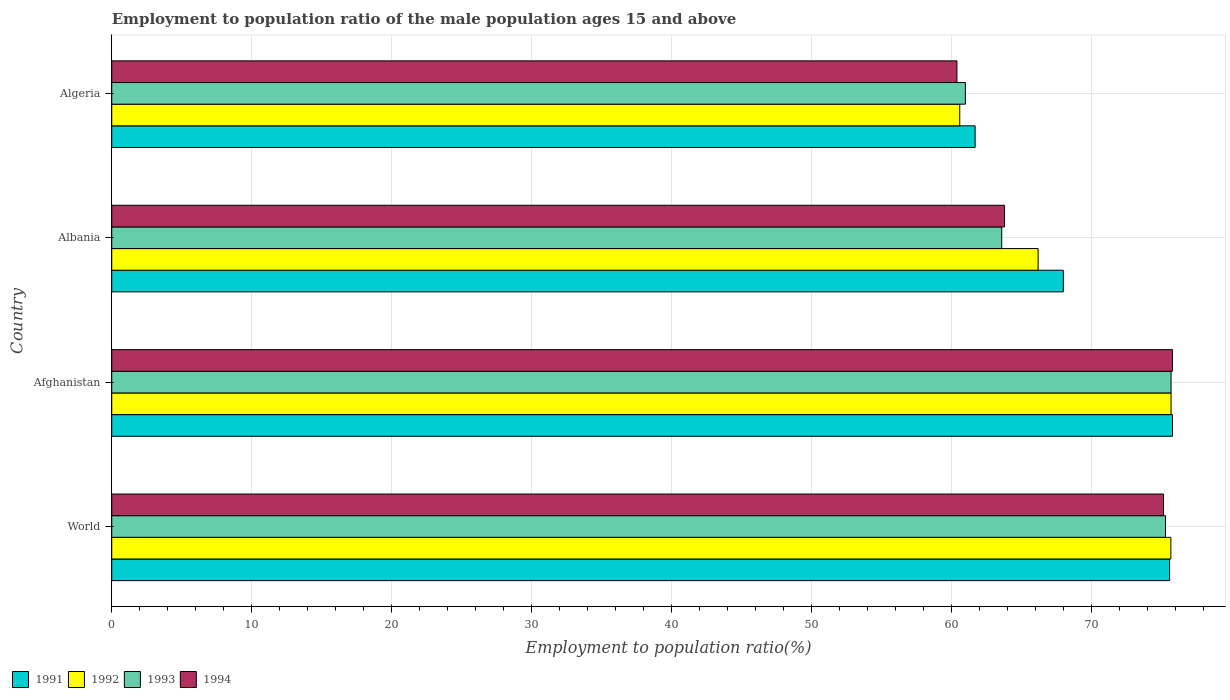Are the number of bars per tick equal to the number of legend labels?
Give a very brief answer. Yes. Are the number of bars on each tick of the Y-axis equal?
Keep it short and to the point. Yes. In how many cases, is the number of bars for a given country not equal to the number of legend labels?
Provide a short and direct response. 0. What is the employment to population ratio in 1994 in Albania?
Offer a terse response. 63.8. Across all countries, what is the maximum employment to population ratio in 1994?
Provide a succinct answer. 75.8. Across all countries, what is the minimum employment to population ratio in 1992?
Offer a terse response. 60.6. In which country was the employment to population ratio in 1993 maximum?
Ensure brevity in your answer.  Afghanistan. In which country was the employment to population ratio in 1994 minimum?
Your answer should be very brief. Algeria. What is the total employment to population ratio in 1994 in the graph?
Provide a succinct answer. 275.16. What is the difference between the employment to population ratio in 1992 in Afghanistan and that in Algeria?
Your answer should be compact. 15.1. What is the difference between the employment to population ratio in 1992 in Afghanistan and the employment to population ratio in 1991 in Algeria?
Provide a short and direct response. 14. What is the average employment to population ratio in 1994 per country?
Your answer should be compact. 68.79. What is the difference between the employment to population ratio in 1993 and employment to population ratio in 1992 in World?
Make the answer very short. -0.38. In how many countries, is the employment to population ratio in 1993 greater than 70 %?
Offer a very short reply. 2. What is the ratio of the employment to population ratio in 1993 in Albania to that in Algeria?
Offer a terse response. 1.04. Is the employment to population ratio in 1992 in Albania less than that in World?
Your response must be concise. Yes. What is the difference between the highest and the second highest employment to population ratio in 1991?
Your answer should be very brief. 0.2. What is the difference between the highest and the lowest employment to population ratio in 1994?
Your answer should be compact. 15.4. In how many countries, is the employment to population ratio in 1993 greater than the average employment to population ratio in 1993 taken over all countries?
Make the answer very short. 2. Is it the case that in every country, the sum of the employment to population ratio in 1991 and employment to population ratio in 1992 is greater than the sum of employment to population ratio in 1994 and employment to population ratio in 1993?
Give a very brief answer. No. What does the 4th bar from the top in Afghanistan represents?
Offer a very short reply. 1991. What does the 3rd bar from the bottom in World represents?
Provide a short and direct response. 1993. Is it the case that in every country, the sum of the employment to population ratio in 1993 and employment to population ratio in 1992 is greater than the employment to population ratio in 1994?
Make the answer very short. Yes. How many bars are there?
Your answer should be compact. 16. What is the difference between two consecutive major ticks on the X-axis?
Make the answer very short. 10. What is the title of the graph?
Make the answer very short. Employment to population ratio of the male population ages 15 and above. What is the label or title of the X-axis?
Offer a terse response. Employment to population ratio(%). What is the Employment to population ratio(%) in 1991 in World?
Ensure brevity in your answer.  75.6. What is the Employment to population ratio(%) in 1992 in World?
Your answer should be compact. 75.69. What is the Employment to population ratio(%) of 1993 in World?
Make the answer very short. 75.3. What is the Employment to population ratio(%) of 1994 in World?
Offer a very short reply. 75.16. What is the Employment to population ratio(%) in 1991 in Afghanistan?
Provide a short and direct response. 75.8. What is the Employment to population ratio(%) in 1992 in Afghanistan?
Give a very brief answer. 75.7. What is the Employment to population ratio(%) in 1993 in Afghanistan?
Provide a short and direct response. 75.7. What is the Employment to population ratio(%) of 1994 in Afghanistan?
Offer a terse response. 75.8. What is the Employment to population ratio(%) of 1991 in Albania?
Keep it short and to the point. 68. What is the Employment to population ratio(%) in 1992 in Albania?
Your response must be concise. 66.2. What is the Employment to population ratio(%) of 1993 in Albania?
Offer a very short reply. 63.6. What is the Employment to population ratio(%) of 1994 in Albania?
Offer a terse response. 63.8. What is the Employment to population ratio(%) of 1991 in Algeria?
Keep it short and to the point. 61.7. What is the Employment to population ratio(%) in 1992 in Algeria?
Give a very brief answer. 60.6. What is the Employment to population ratio(%) of 1993 in Algeria?
Offer a terse response. 61. What is the Employment to population ratio(%) in 1994 in Algeria?
Your response must be concise. 60.4. Across all countries, what is the maximum Employment to population ratio(%) of 1991?
Keep it short and to the point. 75.8. Across all countries, what is the maximum Employment to population ratio(%) in 1992?
Provide a short and direct response. 75.7. Across all countries, what is the maximum Employment to population ratio(%) in 1993?
Provide a short and direct response. 75.7. Across all countries, what is the maximum Employment to population ratio(%) of 1994?
Your answer should be compact. 75.8. Across all countries, what is the minimum Employment to population ratio(%) in 1991?
Your response must be concise. 61.7. Across all countries, what is the minimum Employment to population ratio(%) of 1992?
Offer a terse response. 60.6. Across all countries, what is the minimum Employment to population ratio(%) of 1994?
Make the answer very short. 60.4. What is the total Employment to population ratio(%) in 1991 in the graph?
Provide a short and direct response. 281.1. What is the total Employment to population ratio(%) in 1992 in the graph?
Ensure brevity in your answer.  278.19. What is the total Employment to population ratio(%) in 1993 in the graph?
Offer a terse response. 275.6. What is the total Employment to population ratio(%) of 1994 in the graph?
Offer a very short reply. 275.16. What is the difference between the Employment to population ratio(%) in 1991 in World and that in Afghanistan?
Offer a very short reply. -0.2. What is the difference between the Employment to population ratio(%) in 1992 in World and that in Afghanistan?
Provide a short and direct response. -0.01. What is the difference between the Employment to population ratio(%) of 1993 in World and that in Afghanistan?
Keep it short and to the point. -0.4. What is the difference between the Employment to population ratio(%) of 1994 in World and that in Afghanistan?
Give a very brief answer. -0.64. What is the difference between the Employment to population ratio(%) of 1991 in World and that in Albania?
Your answer should be compact. 7.6. What is the difference between the Employment to population ratio(%) in 1992 in World and that in Albania?
Provide a succinct answer. 9.49. What is the difference between the Employment to population ratio(%) of 1993 in World and that in Albania?
Offer a terse response. 11.7. What is the difference between the Employment to population ratio(%) of 1994 in World and that in Albania?
Give a very brief answer. 11.36. What is the difference between the Employment to population ratio(%) of 1991 in World and that in Algeria?
Keep it short and to the point. 13.9. What is the difference between the Employment to population ratio(%) of 1992 in World and that in Algeria?
Offer a very short reply. 15.09. What is the difference between the Employment to population ratio(%) in 1993 in World and that in Algeria?
Make the answer very short. 14.3. What is the difference between the Employment to population ratio(%) in 1994 in World and that in Algeria?
Make the answer very short. 14.76. What is the difference between the Employment to population ratio(%) in 1992 in Afghanistan and that in Albania?
Ensure brevity in your answer.  9.5. What is the difference between the Employment to population ratio(%) in 1994 in Afghanistan and that in Albania?
Your answer should be compact. 12. What is the difference between the Employment to population ratio(%) of 1993 in Afghanistan and that in Algeria?
Make the answer very short. 14.7. What is the difference between the Employment to population ratio(%) of 1993 in Albania and that in Algeria?
Give a very brief answer. 2.6. What is the difference between the Employment to population ratio(%) in 1991 in World and the Employment to population ratio(%) in 1992 in Afghanistan?
Provide a succinct answer. -0.1. What is the difference between the Employment to population ratio(%) of 1991 in World and the Employment to population ratio(%) of 1993 in Afghanistan?
Your answer should be very brief. -0.1. What is the difference between the Employment to population ratio(%) of 1991 in World and the Employment to population ratio(%) of 1994 in Afghanistan?
Your answer should be very brief. -0.2. What is the difference between the Employment to population ratio(%) in 1992 in World and the Employment to population ratio(%) in 1993 in Afghanistan?
Your answer should be compact. -0.01. What is the difference between the Employment to population ratio(%) of 1992 in World and the Employment to population ratio(%) of 1994 in Afghanistan?
Ensure brevity in your answer.  -0.11. What is the difference between the Employment to population ratio(%) in 1993 in World and the Employment to population ratio(%) in 1994 in Afghanistan?
Offer a terse response. -0.5. What is the difference between the Employment to population ratio(%) in 1991 in World and the Employment to population ratio(%) in 1992 in Albania?
Give a very brief answer. 9.4. What is the difference between the Employment to population ratio(%) of 1991 in World and the Employment to population ratio(%) of 1993 in Albania?
Provide a succinct answer. 12. What is the difference between the Employment to population ratio(%) of 1991 in World and the Employment to population ratio(%) of 1994 in Albania?
Make the answer very short. 11.8. What is the difference between the Employment to population ratio(%) in 1992 in World and the Employment to population ratio(%) in 1993 in Albania?
Provide a succinct answer. 12.09. What is the difference between the Employment to population ratio(%) of 1992 in World and the Employment to population ratio(%) of 1994 in Albania?
Keep it short and to the point. 11.89. What is the difference between the Employment to population ratio(%) of 1993 in World and the Employment to population ratio(%) of 1994 in Albania?
Your response must be concise. 11.5. What is the difference between the Employment to population ratio(%) in 1991 in World and the Employment to population ratio(%) in 1992 in Algeria?
Provide a succinct answer. 15. What is the difference between the Employment to population ratio(%) in 1991 in World and the Employment to population ratio(%) in 1993 in Algeria?
Your answer should be compact. 14.6. What is the difference between the Employment to population ratio(%) in 1991 in World and the Employment to population ratio(%) in 1994 in Algeria?
Your response must be concise. 15.2. What is the difference between the Employment to population ratio(%) in 1992 in World and the Employment to population ratio(%) in 1993 in Algeria?
Your answer should be compact. 14.69. What is the difference between the Employment to population ratio(%) of 1992 in World and the Employment to population ratio(%) of 1994 in Algeria?
Offer a very short reply. 15.29. What is the difference between the Employment to population ratio(%) of 1993 in World and the Employment to population ratio(%) of 1994 in Algeria?
Offer a terse response. 14.9. What is the difference between the Employment to population ratio(%) of 1991 in Afghanistan and the Employment to population ratio(%) of 1994 in Albania?
Your answer should be very brief. 12. What is the difference between the Employment to population ratio(%) of 1992 in Afghanistan and the Employment to population ratio(%) of 1994 in Albania?
Keep it short and to the point. 11.9. What is the difference between the Employment to population ratio(%) in 1991 in Afghanistan and the Employment to population ratio(%) in 1992 in Algeria?
Provide a succinct answer. 15.2. What is the difference between the Employment to population ratio(%) in 1991 in Afghanistan and the Employment to population ratio(%) in 1993 in Algeria?
Offer a very short reply. 14.8. What is the difference between the Employment to population ratio(%) of 1991 in Afghanistan and the Employment to population ratio(%) of 1994 in Algeria?
Provide a succinct answer. 15.4. What is the difference between the Employment to population ratio(%) of 1992 in Afghanistan and the Employment to population ratio(%) of 1993 in Algeria?
Offer a terse response. 14.7. What is the difference between the Employment to population ratio(%) in 1992 in Afghanistan and the Employment to population ratio(%) in 1994 in Algeria?
Provide a short and direct response. 15.3. What is the difference between the Employment to population ratio(%) in 1991 in Albania and the Employment to population ratio(%) in 1992 in Algeria?
Offer a very short reply. 7.4. What is the difference between the Employment to population ratio(%) of 1991 in Albania and the Employment to population ratio(%) of 1994 in Algeria?
Offer a very short reply. 7.6. What is the difference between the Employment to population ratio(%) in 1992 in Albania and the Employment to population ratio(%) in 1993 in Algeria?
Your answer should be very brief. 5.2. What is the average Employment to population ratio(%) of 1991 per country?
Offer a very short reply. 70.27. What is the average Employment to population ratio(%) of 1992 per country?
Offer a terse response. 69.55. What is the average Employment to population ratio(%) in 1993 per country?
Provide a succinct answer. 68.9. What is the average Employment to population ratio(%) of 1994 per country?
Give a very brief answer. 68.79. What is the difference between the Employment to population ratio(%) in 1991 and Employment to population ratio(%) in 1992 in World?
Offer a very short reply. -0.09. What is the difference between the Employment to population ratio(%) of 1991 and Employment to population ratio(%) of 1993 in World?
Offer a terse response. 0.29. What is the difference between the Employment to population ratio(%) in 1991 and Employment to population ratio(%) in 1994 in World?
Your answer should be very brief. 0.43. What is the difference between the Employment to population ratio(%) in 1992 and Employment to population ratio(%) in 1993 in World?
Keep it short and to the point. 0.38. What is the difference between the Employment to population ratio(%) in 1992 and Employment to population ratio(%) in 1994 in World?
Make the answer very short. 0.52. What is the difference between the Employment to population ratio(%) in 1993 and Employment to population ratio(%) in 1994 in World?
Your answer should be very brief. 0.14. What is the difference between the Employment to population ratio(%) of 1992 and Employment to population ratio(%) of 1994 in Afghanistan?
Your answer should be very brief. -0.1. What is the difference between the Employment to population ratio(%) of 1993 and Employment to population ratio(%) of 1994 in Afghanistan?
Keep it short and to the point. -0.1. What is the difference between the Employment to population ratio(%) of 1991 and Employment to population ratio(%) of 1993 in Albania?
Your response must be concise. 4.4. What is the difference between the Employment to population ratio(%) of 1991 and Employment to population ratio(%) of 1994 in Albania?
Ensure brevity in your answer.  4.2. What is the difference between the Employment to population ratio(%) in 1992 and Employment to population ratio(%) in 1993 in Albania?
Provide a succinct answer. 2.6. What is the difference between the Employment to population ratio(%) of 1992 and Employment to population ratio(%) of 1994 in Albania?
Your answer should be very brief. 2.4. What is the difference between the Employment to population ratio(%) of 1993 and Employment to population ratio(%) of 1994 in Albania?
Your response must be concise. -0.2. What is the difference between the Employment to population ratio(%) of 1991 and Employment to population ratio(%) of 1993 in Algeria?
Your answer should be very brief. 0.7. What is the ratio of the Employment to population ratio(%) in 1991 in World to that in Afghanistan?
Your answer should be very brief. 1. What is the ratio of the Employment to population ratio(%) of 1992 in World to that in Afghanistan?
Your response must be concise. 1. What is the ratio of the Employment to population ratio(%) in 1993 in World to that in Afghanistan?
Offer a terse response. 0.99. What is the ratio of the Employment to population ratio(%) of 1991 in World to that in Albania?
Your answer should be very brief. 1.11. What is the ratio of the Employment to population ratio(%) in 1992 in World to that in Albania?
Give a very brief answer. 1.14. What is the ratio of the Employment to population ratio(%) of 1993 in World to that in Albania?
Provide a succinct answer. 1.18. What is the ratio of the Employment to population ratio(%) in 1994 in World to that in Albania?
Provide a short and direct response. 1.18. What is the ratio of the Employment to population ratio(%) in 1991 in World to that in Algeria?
Make the answer very short. 1.23. What is the ratio of the Employment to population ratio(%) of 1992 in World to that in Algeria?
Ensure brevity in your answer.  1.25. What is the ratio of the Employment to population ratio(%) in 1993 in World to that in Algeria?
Offer a terse response. 1.23. What is the ratio of the Employment to population ratio(%) of 1994 in World to that in Algeria?
Your response must be concise. 1.24. What is the ratio of the Employment to population ratio(%) of 1991 in Afghanistan to that in Albania?
Offer a terse response. 1.11. What is the ratio of the Employment to population ratio(%) of 1992 in Afghanistan to that in Albania?
Ensure brevity in your answer.  1.14. What is the ratio of the Employment to population ratio(%) in 1993 in Afghanistan to that in Albania?
Your answer should be very brief. 1.19. What is the ratio of the Employment to population ratio(%) in 1994 in Afghanistan to that in Albania?
Your response must be concise. 1.19. What is the ratio of the Employment to population ratio(%) of 1991 in Afghanistan to that in Algeria?
Make the answer very short. 1.23. What is the ratio of the Employment to population ratio(%) of 1992 in Afghanistan to that in Algeria?
Keep it short and to the point. 1.25. What is the ratio of the Employment to population ratio(%) of 1993 in Afghanistan to that in Algeria?
Your answer should be very brief. 1.24. What is the ratio of the Employment to population ratio(%) of 1994 in Afghanistan to that in Algeria?
Make the answer very short. 1.25. What is the ratio of the Employment to population ratio(%) in 1991 in Albania to that in Algeria?
Give a very brief answer. 1.1. What is the ratio of the Employment to population ratio(%) of 1992 in Albania to that in Algeria?
Your answer should be very brief. 1.09. What is the ratio of the Employment to population ratio(%) in 1993 in Albania to that in Algeria?
Keep it short and to the point. 1.04. What is the ratio of the Employment to population ratio(%) in 1994 in Albania to that in Algeria?
Ensure brevity in your answer.  1.06. What is the difference between the highest and the second highest Employment to population ratio(%) of 1991?
Your answer should be very brief. 0.2. What is the difference between the highest and the second highest Employment to population ratio(%) in 1992?
Your answer should be compact. 0.01. What is the difference between the highest and the second highest Employment to population ratio(%) of 1993?
Your answer should be very brief. 0.4. What is the difference between the highest and the second highest Employment to population ratio(%) of 1994?
Provide a short and direct response. 0.64. What is the difference between the highest and the lowest Employment to population ratio(%) in 1991?
Provide a succinct answer. 14.1. What is the difference between the highest and the lowest Employment to population ratio(%) of 1993?
Make the answer very short. 14.7. 